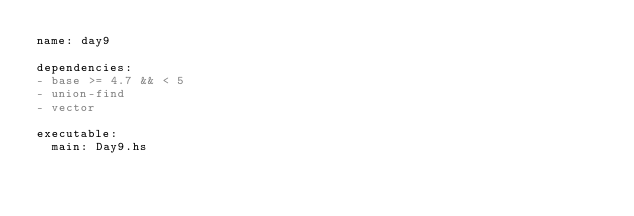Convert code to text. <code><loc_0><loc_0><loc_500><loc_500><_YAML_>name: day9

dependencies:
- base >= 4.7 && < 5
- union-find
- vector

executable:
  main: Day9.hs
</code> 